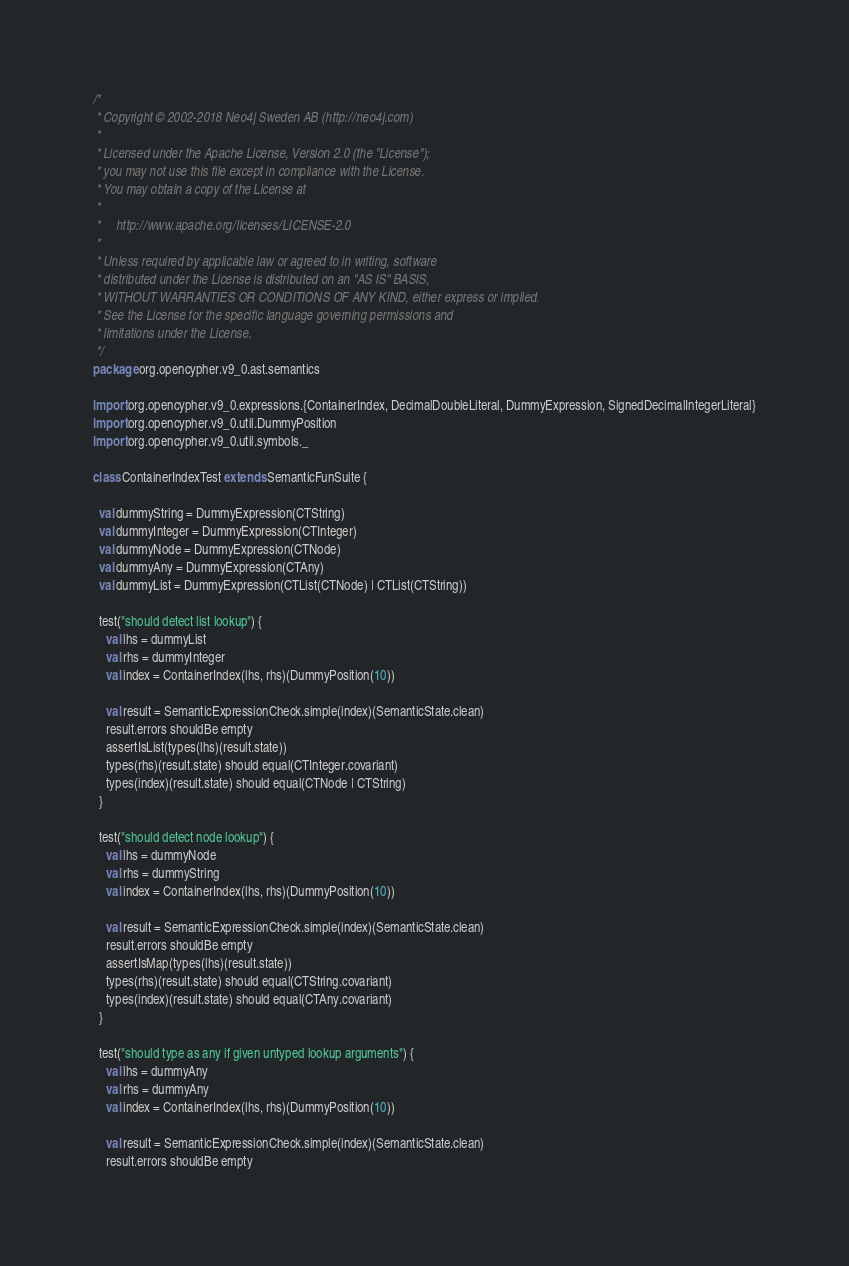Convert code to text. <code><loc_0><loc_0><loc_500><loc_500><_Scala_>/*
 * Copyright © 2002-2018 Neo4j Sweden AB (http://neo4j.com)
 *
 * Licensed under the Apache License, Version 2.0 (the "License");
 * you may not use this file except in compliance with the License.
 * You may obtain a copy of the License at
 *
 *     http://www.apache.org/licenses/LICENSE-2.0
 *
 * Unless required by applicable law or agreed to in writing, software
 * distributed under the License is distributed on an "AS IS" BASIS,
 * WITHOUT WARRANTIES OR CONDITIONS OF ANY KIND, either express or implied.
 * See the License for the specific language governing permissions and
 * limitations under the License.
 */
package org.opencypher.v9_0.ast.semantics

import org.opencypher.v9_0.expressions.{ContainerIndex, DecimalDoubleLiteral, DummyExpression, SignedDecimalIntegerLiteral}
import org.opencypher.v9_0.util.DummyPosition
import org.opencypher.v9_0.util.symbols._

class ContainerIndexTest extends SemanticFunSuite {

  val dummyString = DummyExpression(CTString)
  val dummyInteger = DummyExpression(CTInteger)
  val dummyNode = DummyExpression(CTNode)
  val dummyAny = DummyExpression(CTAny)
  val dummyList = DummyExpression(CTList(CTNode) | CTList(CTString))

  test("should detect list lookup") {
    val lhs = dummyList
    val rhs = dummyInteger
    val index = ContainerIndex(lhs, rhs)(DummyPosition(10))

    val result = SemanticExpressionCheck.simple(index)(SemanticState.clean)
    result.errors shouldBe empty
    assertIsList(types(lhs)(result.state))
    types(rhs)(result.state) should equal(CTInteger.covariant)
    types(index)(result.state) should equal(CTNode | CTString)
  }

  test("should detect node lookup") {
    val lhs = dummyNode
    val rhs = dummyString
    val index = ContainerIndex(lhs, rhs)(DummyPosition(10))

    val result = SemanticExpressionCheck.simple(index)(SemanticState.clean)
    result.errors shouldBe empty
    assertIsMap(types(lhs)(result.state))
    types(rhs)(result.state) should equal(CTString.covariant)
    types(index)(result.state) should equal(CTAny.covariant)
  }

  test("should type as any if given untyped lookup arguments") {
    val lhs = dummyAny
    val rhs = dummyAny
    val index = ContainerIndex(lhs, rhs)(DummyPosition(10))

    val result = SemanticExpressionCheck.simple(index)(SemanticState.clean)
    result.errors shouldBe empty</code> 